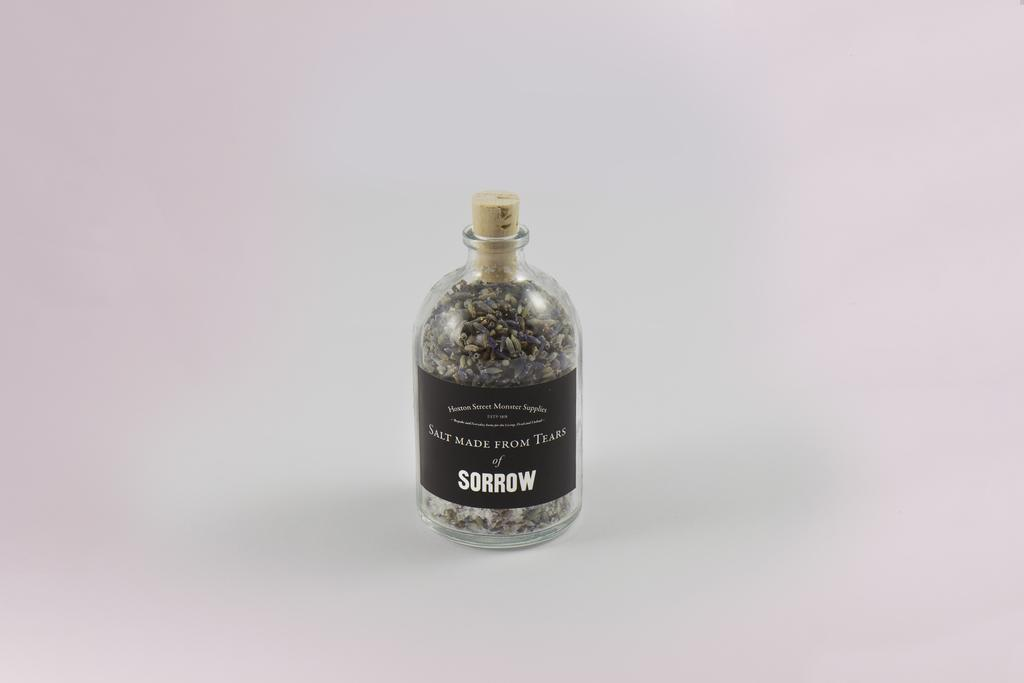What object is present in the image with a cork? There is a bottle in the image with a cork. What feature is on the bottle? The bottle has a label on it. How many kittens are playing with the snails on the label of the bottle? There are no kittens or snails present on the label of the bottle; the label features a different design or text. 